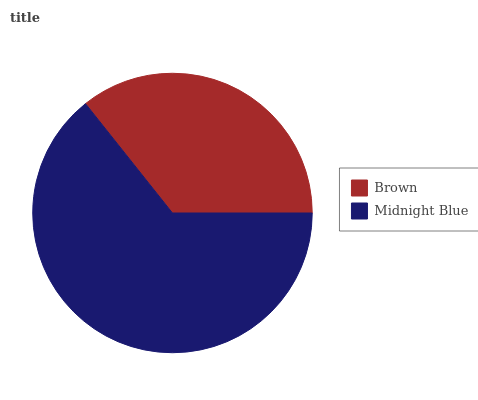Is Brown the minimum?
Answer yes or no. Yes. Is Midnight Blue the maximum?
Answer yes or no. Yes. Is Midnight Blue the minimum?
Answer yes or no. No. Is Midnight Blue greater than Brown?
Answer yes or no. Yes. Is Brown less than Midnight Blue?
Answer yes or no. Yes. Is Brown greater than Midnight Blue?
Answer yes or no. No. Is Midnight Blue less than Brown?
Answer yes or no. No. Is Midnight Blue the high median?
Answer yes or no. Yes. Is Brown the low median?
Answer yes or no. Yes. Is Brown the high median?
Answer yes or no. No. Is Midnight Blue the low median?
Answer yes or no. No. 